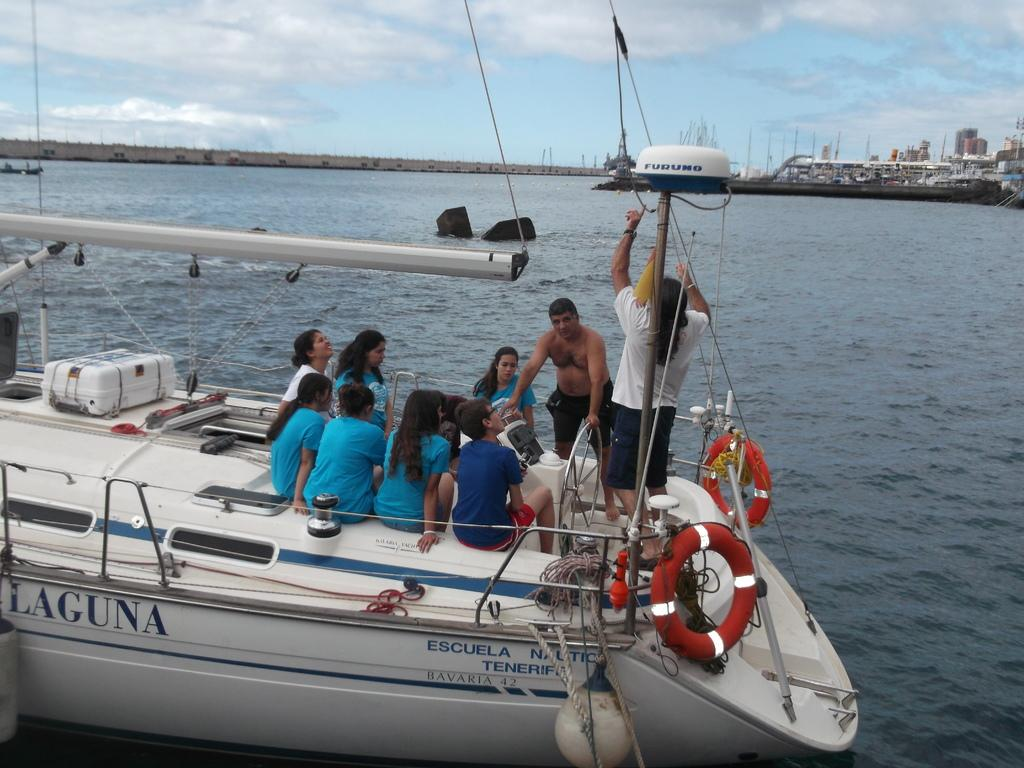<image>
Describe the image concisely. Lots of people on board the Laguna, ready to head out. 